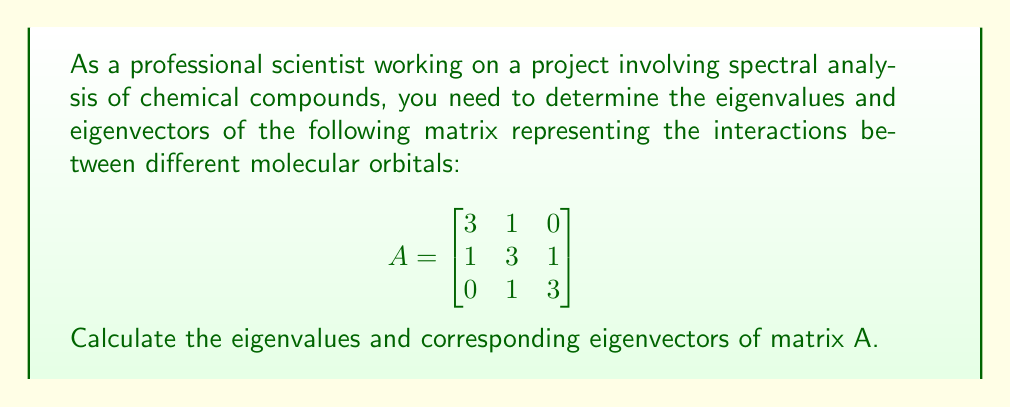Give your solution to this math problem. To find the eigenvalues and eigenvectors of matrix A, we'll follow these steps:

1. Find the characteristic equation:
   $det(A - \lambda I) = 0$
   
   $$\begin{vmatrix}
   3-\lambda & 1 & 0 \\
   1 & 3-\lambda & 1 \\
   0 & 1 & 3-\lambda
   \end{vmatrix} = 0$$

2. Expand the determinant:
   $(3-\lambda)[(3-\lambda)(3-\lambda) - 1] - 1(1)(3-\lambda) + 0 = 0$
   $(3-\lambda)[(3-\lambda)^2 - 1] - 1(3-\lambda) = 0$
   $(3-\lambda)^3 - (3-\lambda) - (3-\lambda) = 0$
   $(3-\lambda)^3 - 2(3-\lambda) = 0$

3. Factor the equation:
   $(3-\lambda)[(3-\lambda)^2 - 2] = 0$
   $(3-\lambda)(3-\lambda+\sqrt{2})(3-\lambda-\sqrt{2}) = 0$

4. Solve for $\lambda$ (eigenvalues):
   $\lambda_1 = 3$
   $\lambda_2 = 3-\sqrt{2}$
   $\lambda_3 = 3+\sqrt{2}$

5. Find eigenvectors for each eigenvalue:
   For $\lambda_1 = 3$:
   $(A - 3I)v = 0$
   $$\begin{bmatrix}
   0 & 1 & 0 \\
   1 & 0 & 1 \\
   0 & 1 & 0
   \end{bmatrix}\begin{bmatrix}
   v_1 \\ v_2 \\ v_3
   \end{bmatrix} = \begin{bmatrix}
   0 \\ 0 \\ 0
   \end{bmatrix}$$
   
   Solving this system: $v_2 = 0$, $v_1 = -v_3$
   Eigenvector: $v_1 = \begin{bmatrix} 1 \\ 0 \\ -1 \end{bmatrix}$

   For $\lambda_2 = 3-\sqrt{2}$:
   $(A - (3-\sqrt{2})I)v = 0$
   $$\begin{bmatrix}
   \sqrt{2} & 1 & 0 \\
   1 & \sqrt{2} & 1 \\
   0 & 1 & \sqrt{2}
   \end{bmatrix}\begin{bmatrix}
   v_1 \\ v_2 \\ v_3
   \end{bmatrix} = \begin{bmatrix}
   0 \\ 0 \\ 0
   \end{bmatrix}$$
   
   Solving this system: $v_2 = -\sqrt{2}v_1$, $v_3 = v_1$
   Eigenvector: $v_2 = \begin{bmatrix} 1 \\ -\sqrt{2} \\ 1 \end{bmatrix}$

   For $\lambda_3 = 3+\sqrt{2}$:
   $(A - (3+\sqrt{2})I)v = 0$
   $$\begin{bmatrix}
   -\sqrt{2} & 1 & 0 \\
   1 & -\sqrt{2} & 1 \\
   0 & 1 & -\sqrt{2}
   \end{bmatrix}\begin{bmatrix}
   v_1 \\ v_2 \\ v_3
   \end{bmatrix} = \begin{bmatrix}
   0 \\ 0 \\ 0
   \end{bmatrix}$$
   
   Solving this system: $v_2 = \sqrt{2}v_1$, $v_3 = v_1$
   Eigenvector: $v_3 = \begin{bmatrix} 1 \\ \sqrt{2} \\ 1 \end{bmatrix}$
Answer: Eigenvalues: $\lambda_1 = 3$, $\lambda_2 = 3-\sqrt{2}$, $\lambda_3 = 3+\sqrt{2}$
Eigenvectors: $v_1 = \begin{bmatrix} 1 \\ 0 \\ -1 \end{bmatrix}$, $v_2 = \begin{bmatrix} 1 \\ -\sqrt{2} \\ 1 \end{bmatrix}$, $v_3 = \begin{bmatrix} 1 \\ \sqrt{2} \\ 1 \end{bmatrix}$ 